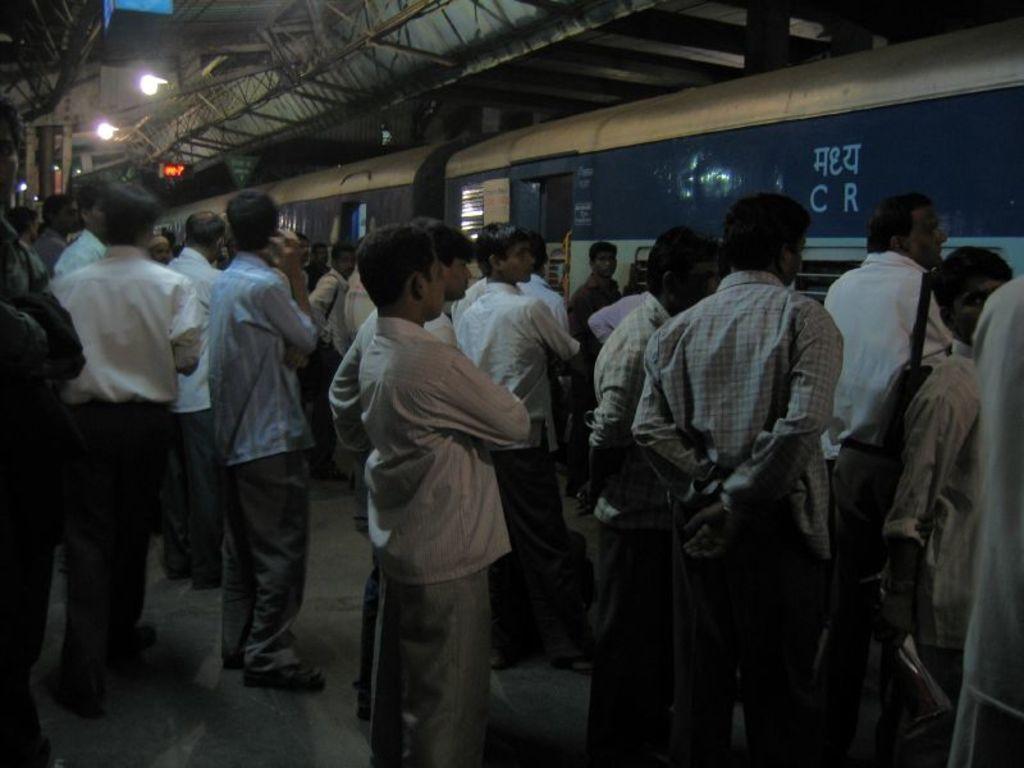Could you give a brief overview of what you see in this image? This is a railway station. Here I can see a crowd of people standing on the platform facing towards the right side. On the right side there is a train. At the top of the image there are many metal rods and also I can see two lights. 